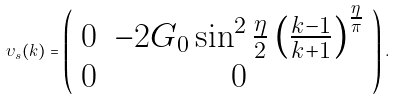Convert formula to latex. <formula><loc_0><loc_0><loc_500><loc_500>\upsilon _ { s } ( k ) = \left ( \begin{array} { c c } 0 & - 2 G _ { 0 } \sin ^ { 2 } \frac { \eta } { 2 } \left ( \frac { k - 1 } { k + 1 } \right ) ^ { \frac { \eta } { \pi } } \\ 0 & 0 \end{array} \right ) .</formula> 